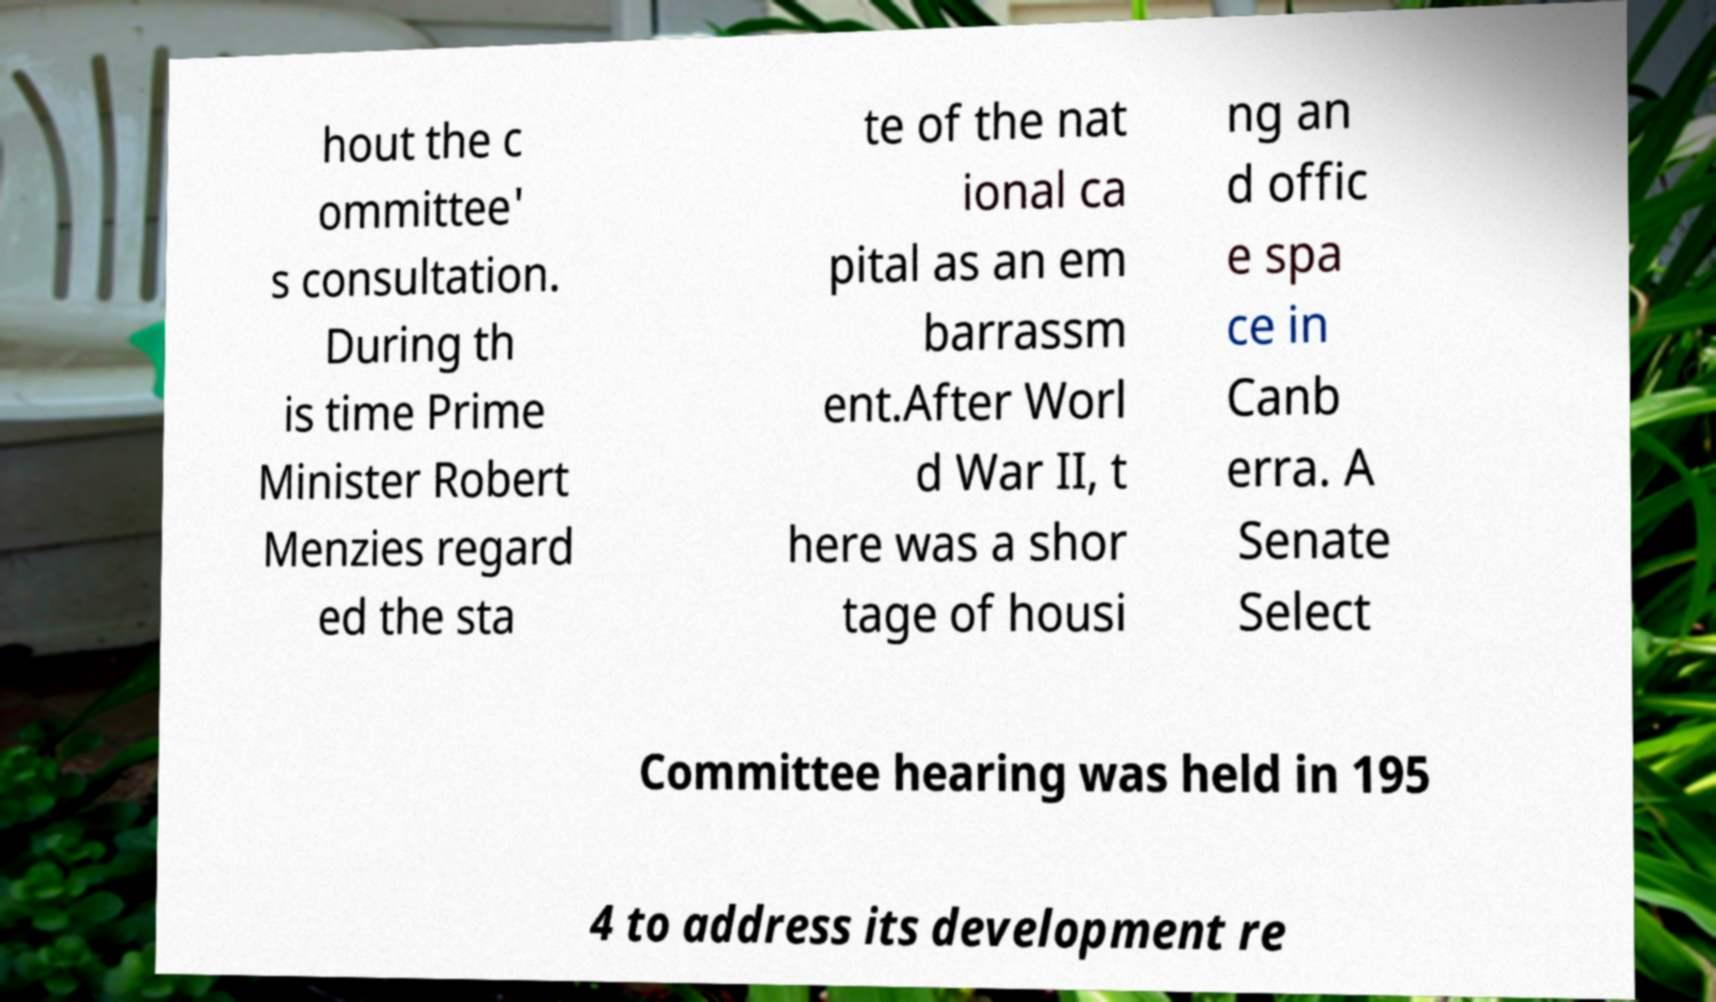Could you assist in decoding the text presented in this image and type it out clearly? hout the c ommittee' s consultation. During th is time Prime Minister Robert Menzies regard ed the sta te of the nat ional ca pital as an em barrassm ent.After Worl d War II, t here was a shor tage of housi ng an d offic e spa ce in Canb erra. A Senate Select Committee hearing was held in 195 4 to address its development re 